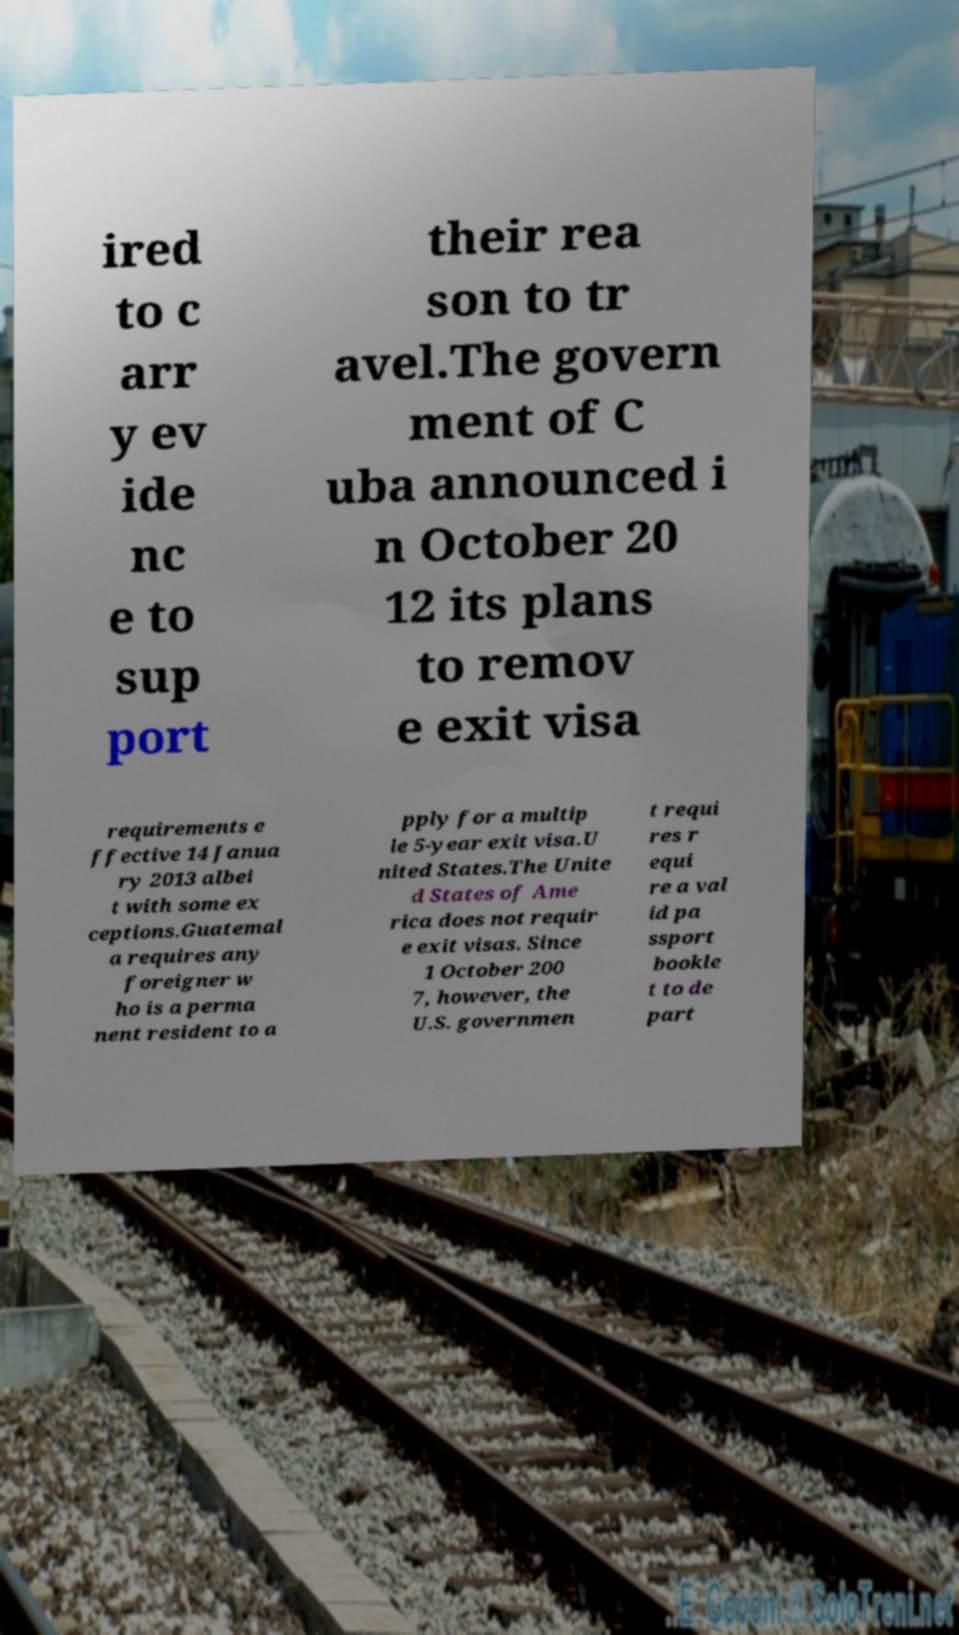Please identify and transcribe the text found in this image. ired to c arr y ev ide nc e to sup port their rea son to tr avel.The govern ment of C uba announced i n October 20 12 its plans to remov e exit visa requirements e ffective 14 Janua ry 2013 albei t with some ex ceptions.Guatemal a requires any foreigner w ho is a perma nent resident to a pply for a multip le 5-year exit visa.U nited States.The Unite d States of Ame rica does not requir e exit visas. Since 1 October 200 7, however, the U.S. governmen t requi res r equi re a val id pa ssport bookle t to de part 